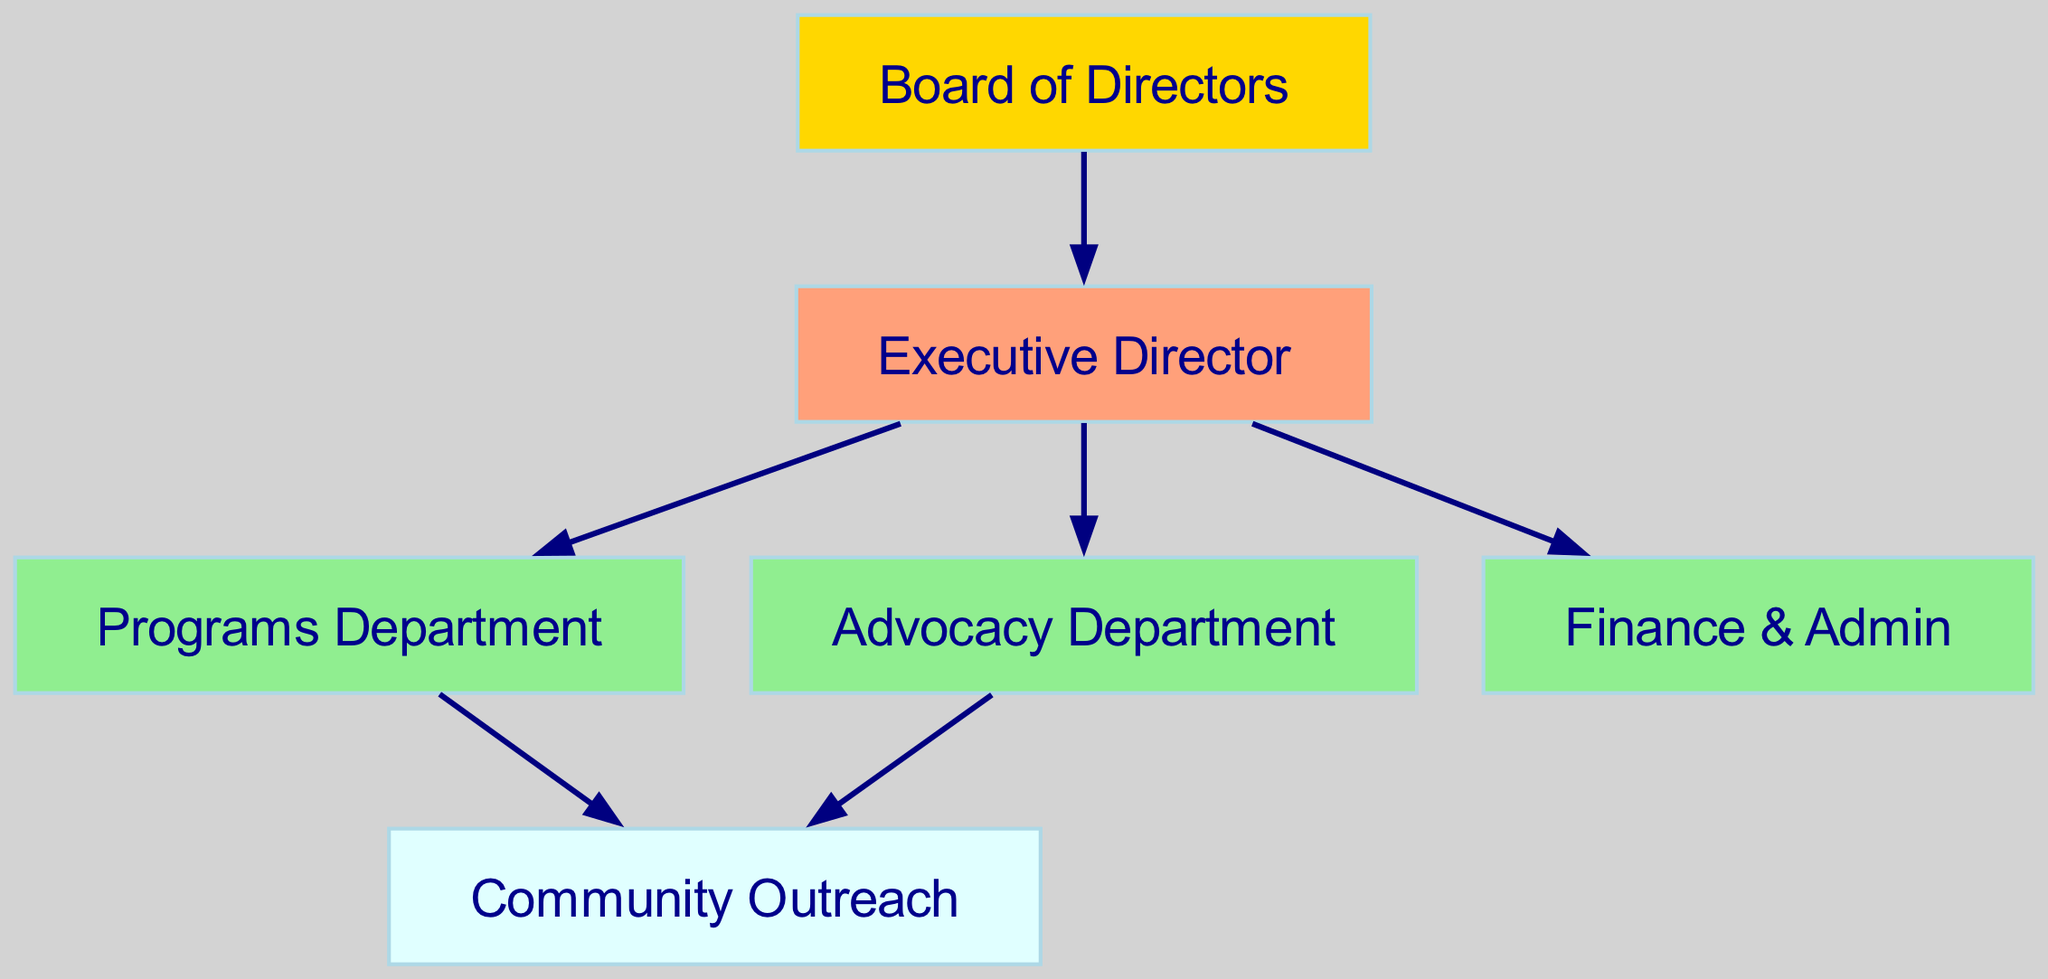What is the top node in the organizational structure? The top node, based on the hierarchy in the diagram, is the "Board of Directors". This can be identified as it has no incoming edges, indicating it does not report to any other department.
Answer: Board of Directors How many departments report directly to the Executive Director? By examining the edges emanating from the "Executive Director" node, we can see that there are three direct reports: "Programs Department", "Advocacy Department", and "Finance & Admin". Thus, the total number is three.
Answer: 3 Which department is responsible for Community Outreach? The "Community Outreach" is a terminal node that receives edges from both the "Programs Department" and "Advocacy Department". This indicates that its primary function is to disseminate the work or goals of these two departments into the community.
Answer: Community Outreach What is the relationship between the Advocacy Department and the Outreach? The "Advocacy Department" has a direct edge leading to "Community Outreach", meaning it influences or contributes directly to outreach efforts. The relationship can thus be described as a direct line of communication or activity leading to outreach.
Answer: Direct influence How many total nodes are present in the diagram? By counting all the box-like shapes present in the diagram, I identified six nodes: "Board of Directors", "Executive Director", "Programs Department", "Advocacy Department", "Finance & Admin", and "Community Outreach". Therefore, the total number of nodes is six.
Answer: 6 Which department does Finance & Admin report to? The "Finance & Admin" department has an arrow pointing from the "Executive Director" to it, indicating that it reports directly to the Executive Director. This establishes its position in the hierarchy as functioning under the executive leadership.
Answer: Executive Director What is the color assigned to the Board of Directors node? In the diagram, the "Board of Directors" is visually distinguished by the color gold, as defined in the node color settings of the diagram. This indicates its higher hierarchical status compared to other departments.
Answer: Gold Which department has the same color as Programs Department? The "Programs Department" shares the same color, light green, with the "Advocacy Department" and "Finance & Admin". This indicates that they are at a similar level in the hierarchy under the Executive Director.
Answer: Advocacy Department, Finance & Admin 